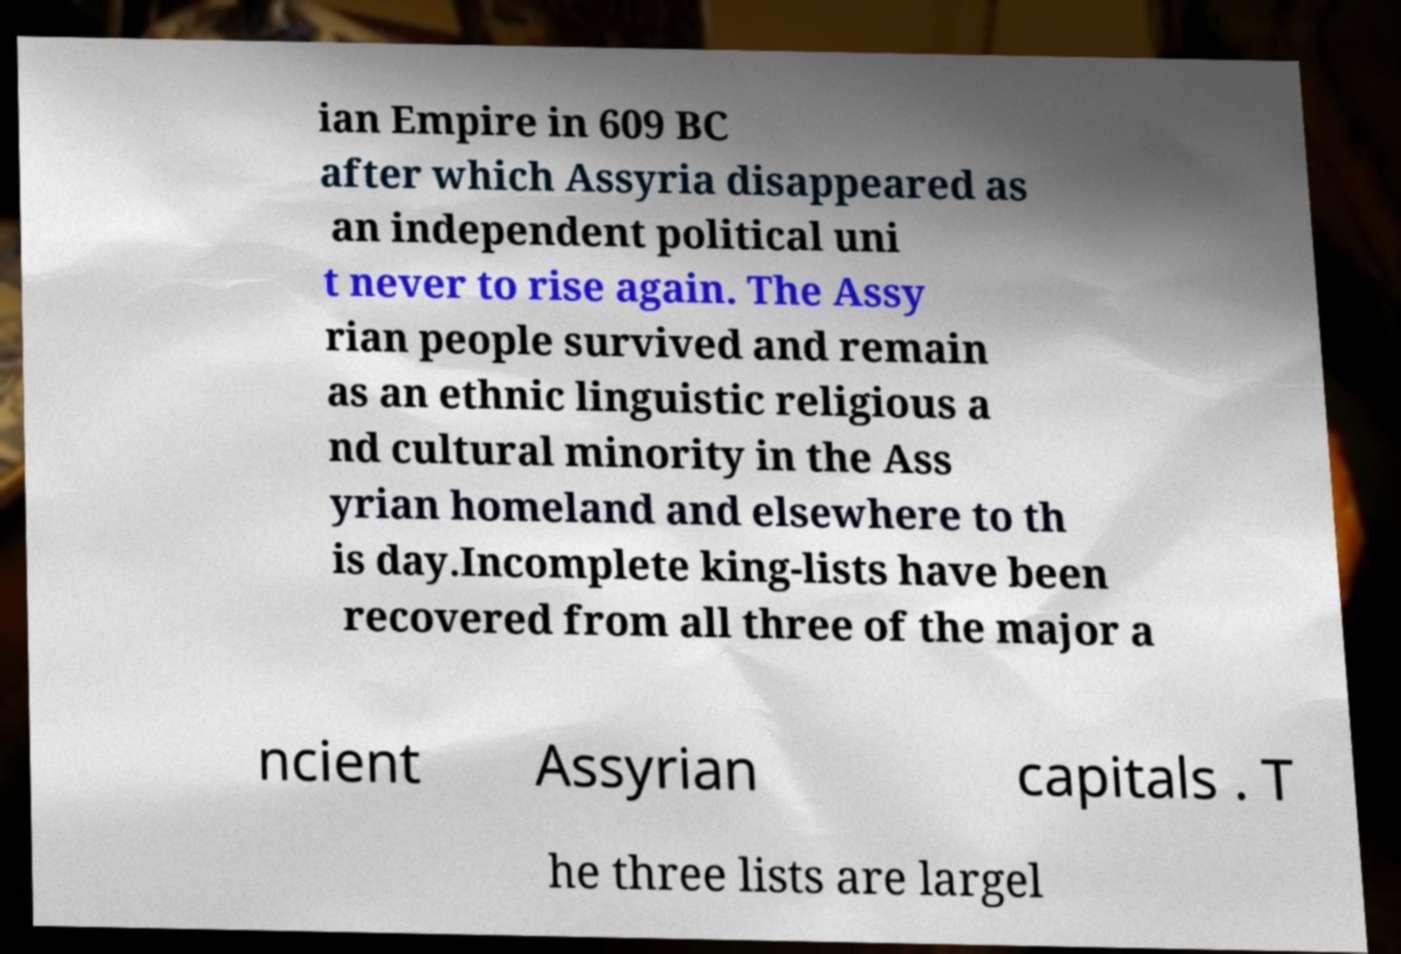Can you accurately transcribe the text from the provided image for me? ian Empire in 609 BC after which Assyria disappeared as an independent political uni t never to rise again. The Assy rian people survived and remain as an ethnic linguistic religious a nd cultural minority in the Ass yrian homeland and elsewhere to th is day.Incomplete king-lists have been recovered from all three of the major a ncient Assyrian capitals . T he three lists are largel 